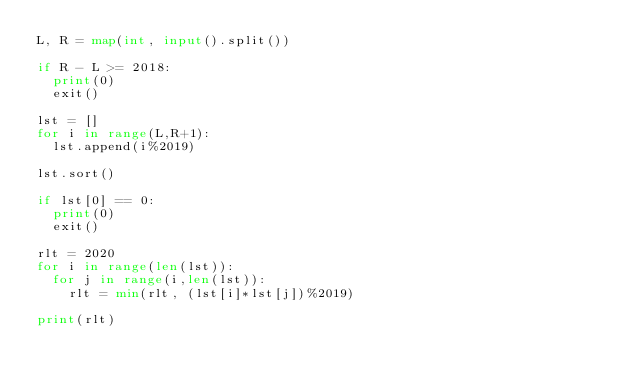Convert code to text. <code><loc_0><loc_0><loc_500><loc_500><_Python_>L, R = map(int, input().split())
  
if R - L >= 2018:
  print(0)
  exit()
  
lst = []
for i in range(L,R+1):
  lst.append(i%2019)
  
lst.sort()

if lst[0] == 0:
  print(0)
  exit()
  
rlt = 2020
for i in range(len(lst)):
  for j in range(i,len(lst)):
    rlt = min(rlt, (lst[i]*lst[j])%2019)
    
print(rlt)</code> 